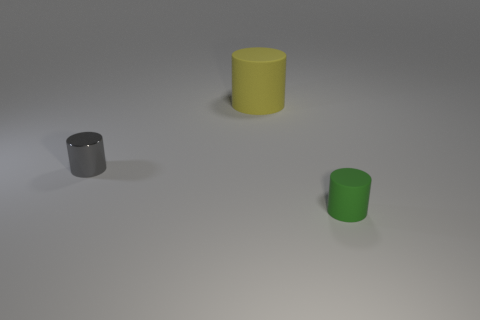How many gray cylinders are there?
Offer a terse response. 1. Is the size of the yellow cylinder the same as the matte thing that is in front of the shiny object?
Ensure brevity in your answer.  No. What is the material of the small cylinder behind the tiny object in front of the gray shiny cylinder?
Make the answer very short. Metal. There is a cylinder that is in front of the tiny cylinder that is behind the matte object in front of the large rubber cylinder; what size is it?
Offer a very short reply. Small. Do the small green rubber object and the matte object behind the gray metallic thing have the same shape?
Make the answer very short. Yes. What is the material of the yellow cylinder?
Keep it short and to the point. Rubber. What number of matte things are small gray cylinders or brown spheres?
Provide a short and direct response. 0. Is the number of rubber objects that are behind the tiny gray metal object less than the number of yellow cylinders that are left of the big object?
Offer a terse response. No. Are there any big cylinders in front of the cylinder that is behind the object to the left of the large yellow matte cylinder?
Ensure brevity in your answer.  No. Is the shape of the tiny object behind the tiny green rubber thing the same as the matte object behind the metallic cylinder?
Your answer should be very brief. Yes. 